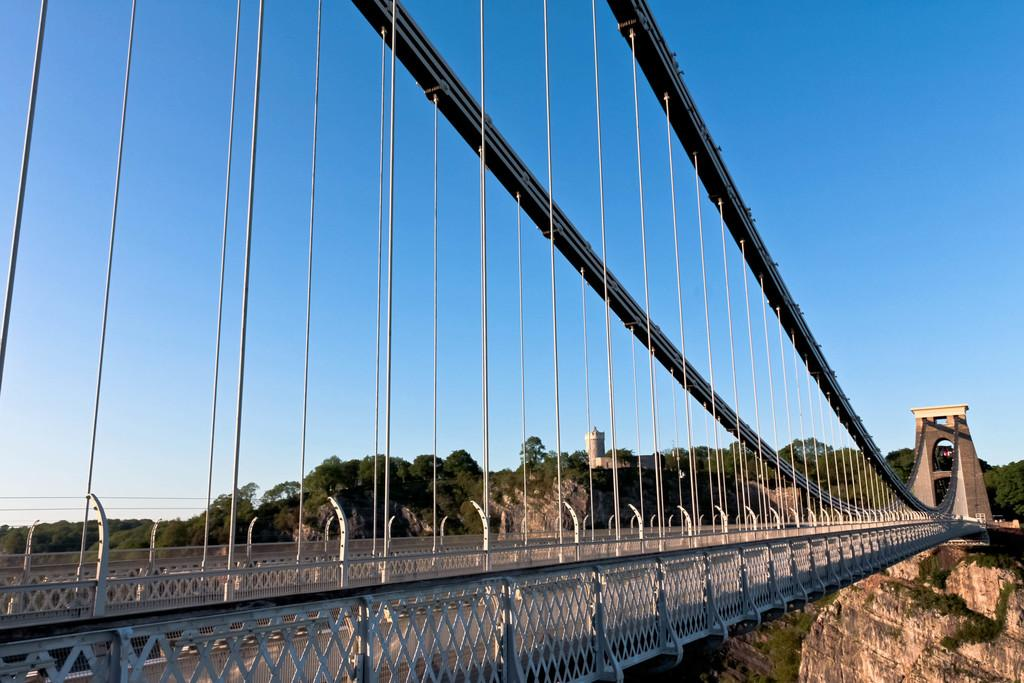What type of structure is present in the image? There is a bridge in the image. What safety features can be seen on the bridge? Railings are present in the image. What other objects are visible on the bridge? Poles are visible in the image. What can be seen in the background of the image? There are trees, a building, and the sky visible in the background of the image. What type of science experiment is being conducted on the bridge in the image? There is no science experiment present in the image; it only features a bridge with railings and poles. Can you tell me how many maids are working in the building in the background? There is no information about maids or the building's interior in the image, so it cannot be determined. 